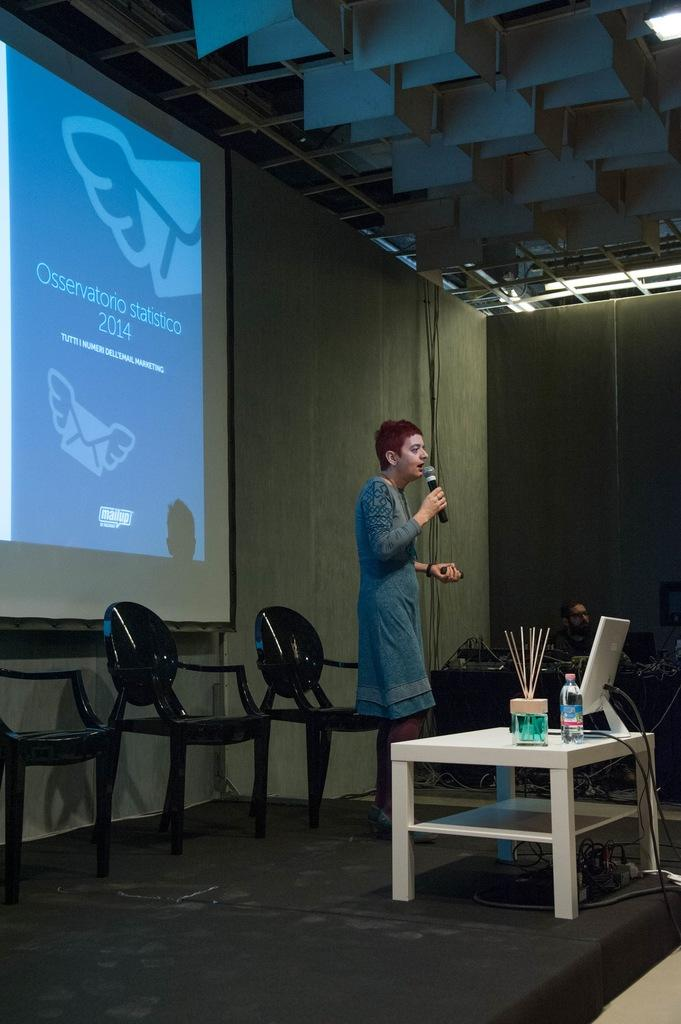<image>
Summarize the visual content of the image. A woman gives a speech under a large screen with the headline Osservatorio statistico 2014. 